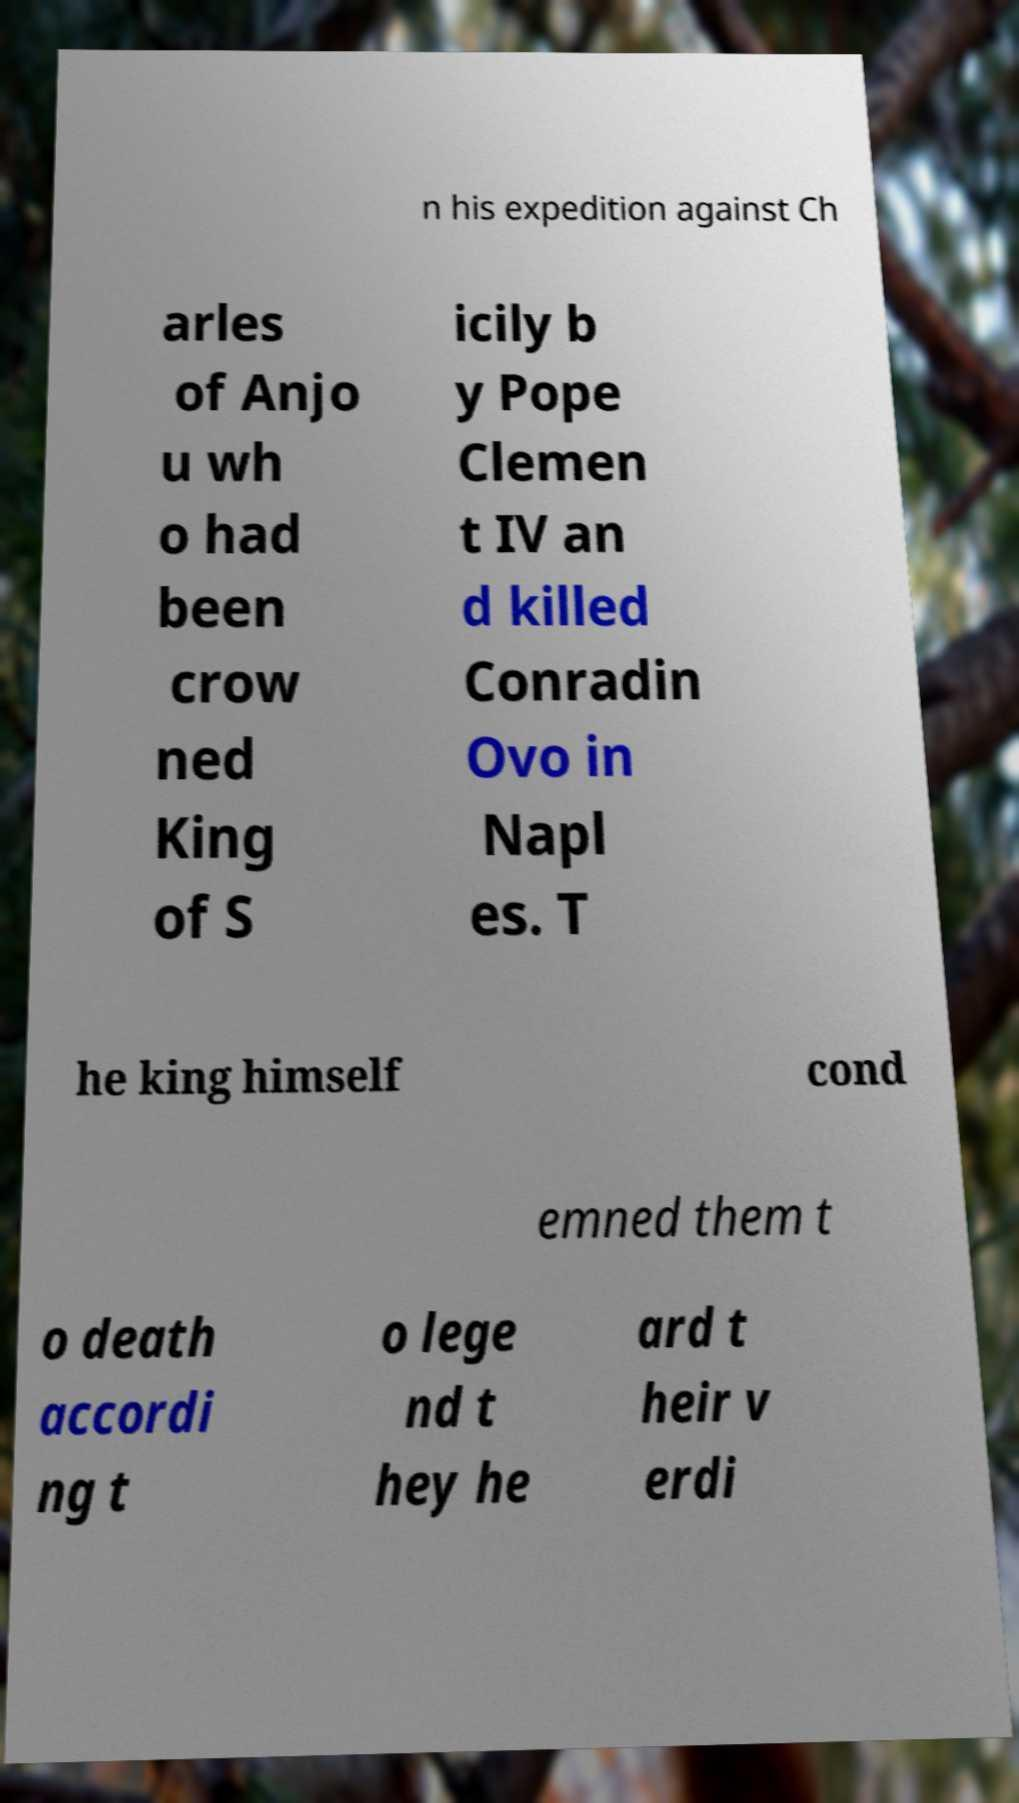Could you extract and type out the text from this image? n his expedition against Ch arles of Anjo u wh o had been crow ned King of S icily b y Pope Clemen t IV an d killed Conradin Ovo in Napl es. T he king himself cond emned them t o death accordi ng t o lege nd t hey he ard t heir v erdi 